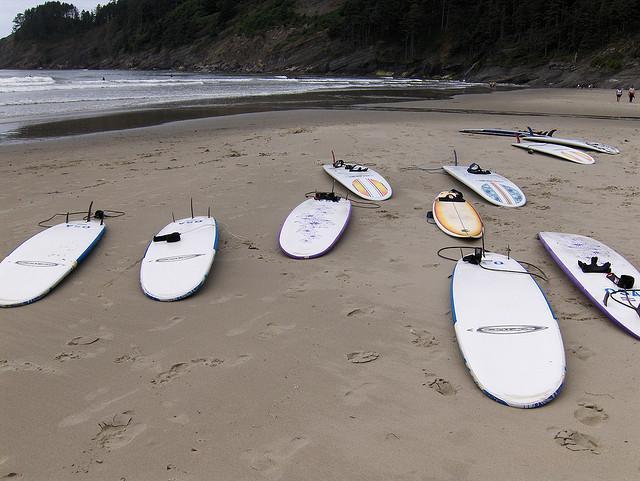How many surfboards are there?
Give a very brief answer. 11. How many surfboards can you see?
Give a very brief answer. 5. How many horses are looking at the camera?
Give a very brief answer. 0. 